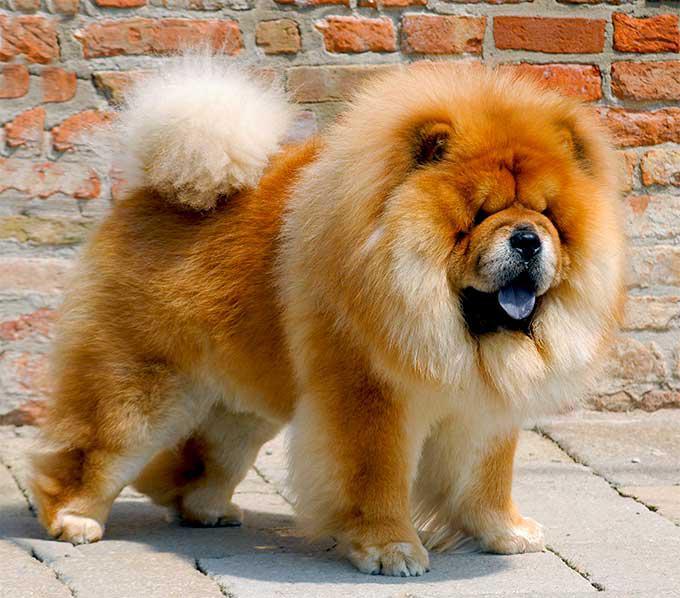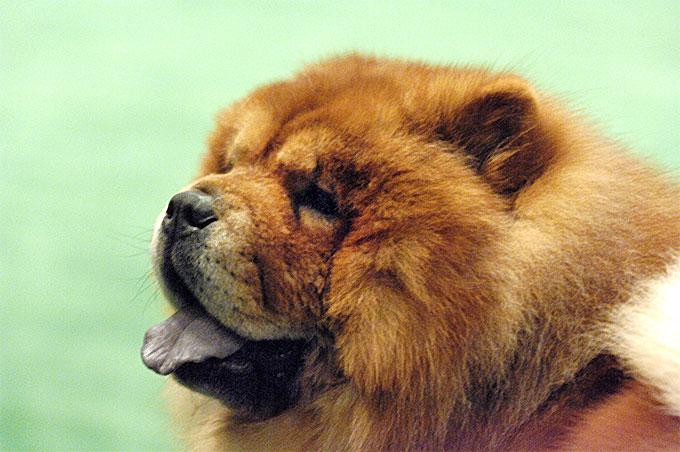The first image is the image on the left, the second image is the image on the right. Analyze the images presented: Is the assertion "A chow dog is shown standing on brick." valid? Answer yes or no. Yes. 